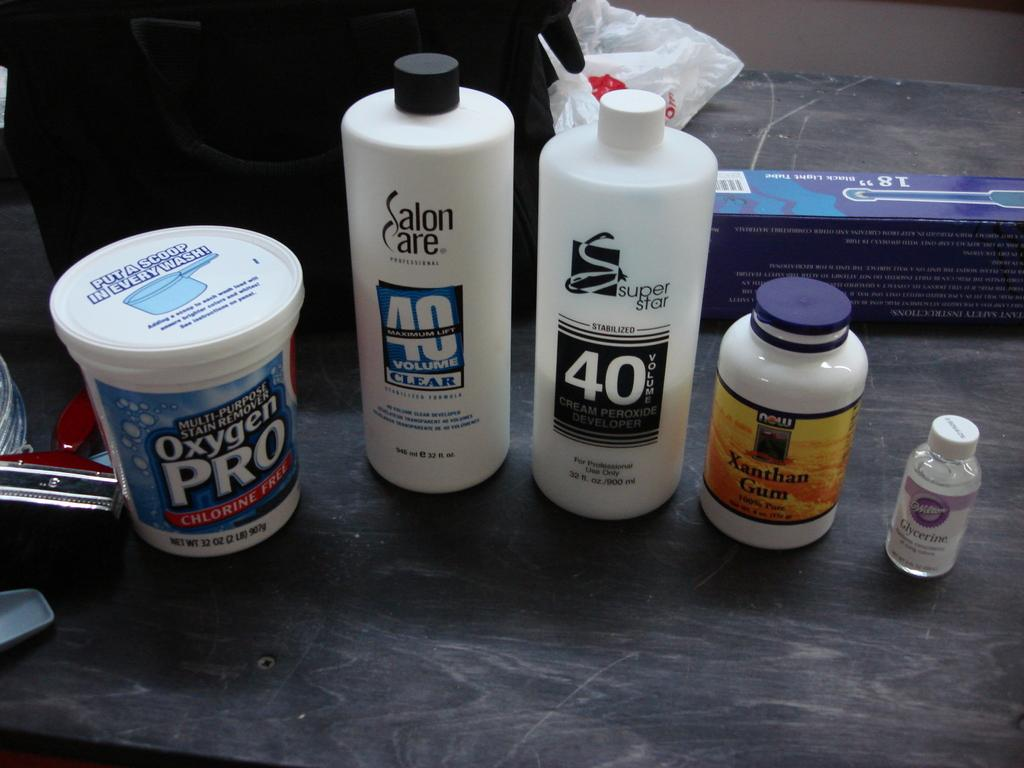Provide a one-sentence caption for the provided image. are products Oxygen PRO, Salon Care 40 Volume Clear, super star 40, and Xanthan Gum on a flat surface. 